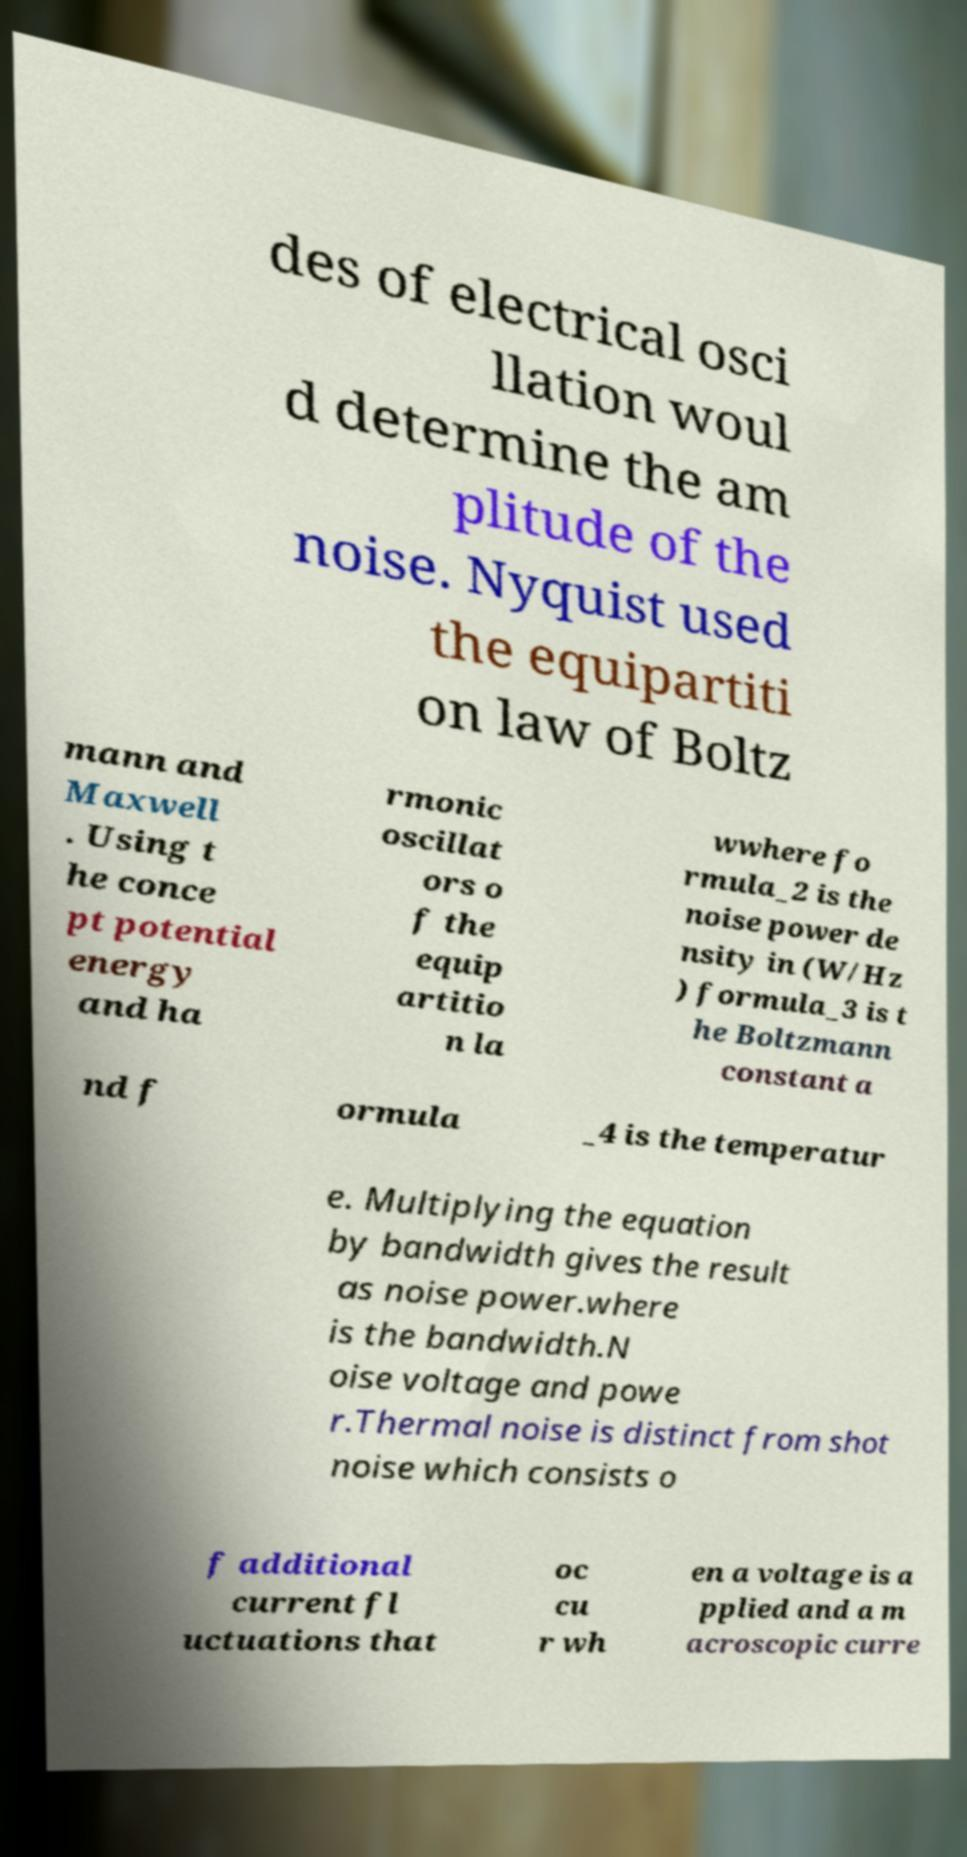For documentation purposes, I need the text within this image transcribed. Could you provide that? des of electrical osci llation woul d determine the am plitude of the noise. Nyquist used the equipartiti on law of Boltz mann and Maxwell . Using t he conce pt potential energy and ha rmonic oscillat ors o f the equip artitio n la wwhere fo rmula_2 is the noise power de nsity in (W/Hz ) formula_3 is t he Boltzmann constant a nd f ormula _4 is the temperatur e. Multiplying the equation by bandwidth gives the result as noise power.where is the bandwidth.N oise voltage and powe r.Thermal noise is distinct from shot noise which consists o f additional current fl uctuations that oc cu r wh en a voltage is a pplied and a m acroscopic curre 